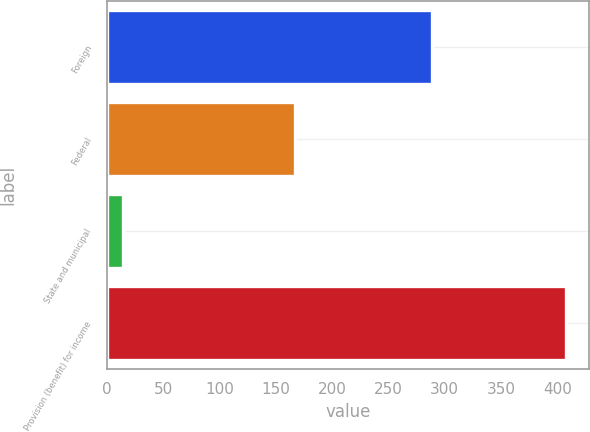Convert chart to OTSL. <chart><loc_0><loc_0><loc_500><loc_500><bar_chart><fcel>Foreign<fcel>Federal<fcel>State and municipal<fcel>Provision (benefit) for income<nl><fcel>289<fcel>167<fcel>14<fcel>408<nl></chart> 